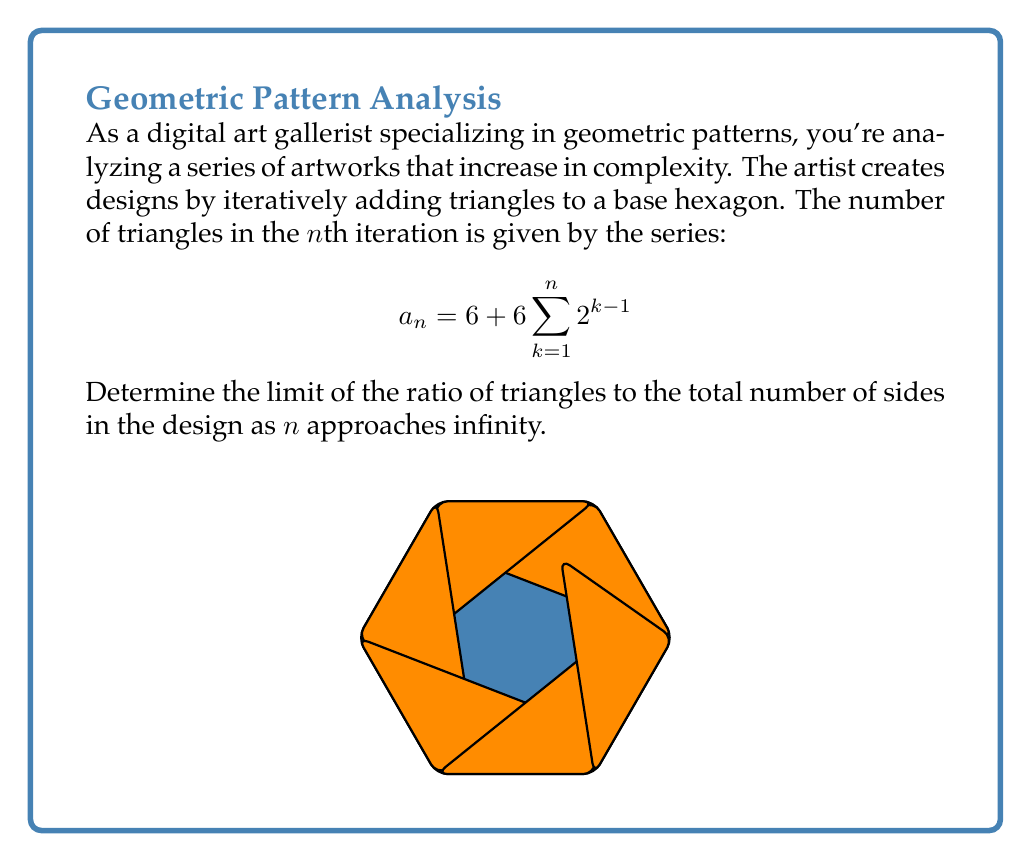Can you solve this math problem? Let's approach this step-by-step:

1) First, we need to simplify the series for $a_n$:
   $$a_n = 6 + 6 \sum_{k=1}^{n} 2^{k-1}$$

2) The sum of a geometric series is given by:
   $$\sum_{k=1}^{n} ar^{k-1} = a\frac{1-r^n}{1-r}$$
   where $a=6$, $r=2$

3) Applying this to our series:
   $$a_n = 6 + 6 \cdot \frac{1-2^n}{1-2} = 6 + 6(2^n - 1) = 6 \cdot 2^n$$

4) Now, let's consider the total number of sides. Each triangle adds 2 new sides, so:
   Total sides = $6 + 2a_n = 6 + 2(6 \cdot 2^n) = 6 + 12 \cdot 2^n$

5) The ratio of triangles to total sides is:
   $$\frac{\text{Triangles}}{\text{Total Sides}} = \frac{6 \cdot 2^n}{6 + 12 \cdot 2^n}$$

6) To find the limit as n approaches infinity:
   $$\lim_{n \to \infty} \frac{6 \cdot 2^n}{6 + 12 \cdot 2^n} = \lim_{n \to \infty} \frac{6}{6 \cdot 2^{-n} + 12}$$

7) As $n$ approaches infinity, $2^{-n}$ approaches 0, so:
   $$\lim_{n \to \infty} \frac{6}{6 \cdot 2^{-n} + 12} = \frac{6}{0 + 12} = \frac{1}{2}$$

Therefore, the limit of the ratio of triangles to total sides as n approaches infinity is 1/2.
Answer: $\frac{1}{2}$ 